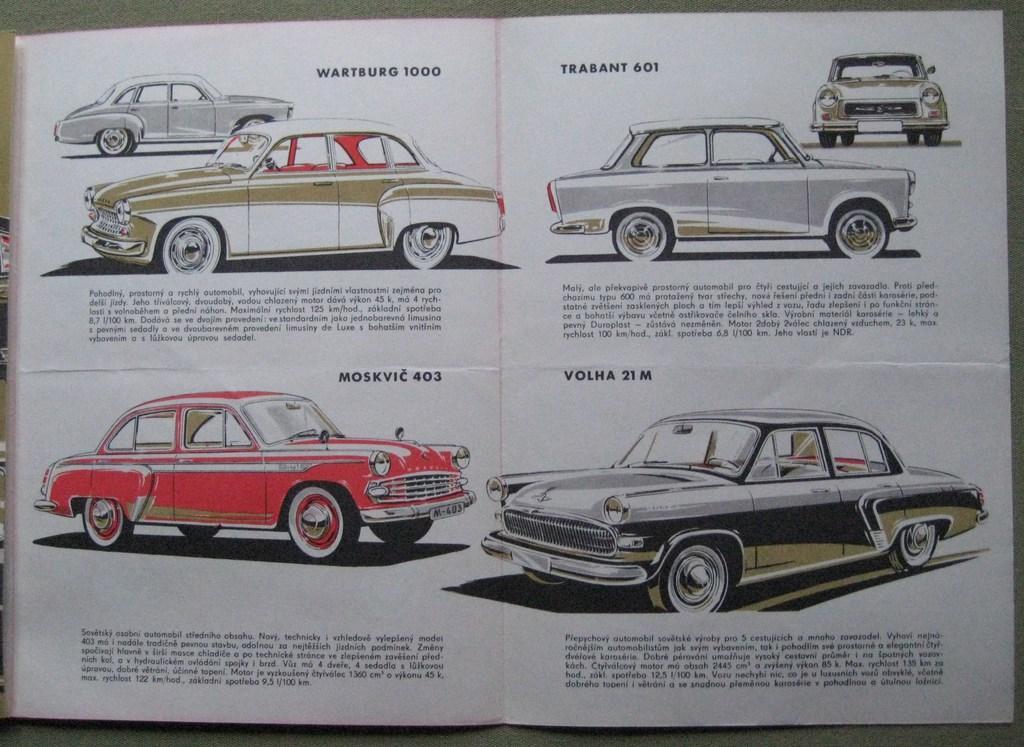Could you give a brief overview of what you see in this image? In the center of the image, we can see a paper and here we can see vehicles and there is text. 